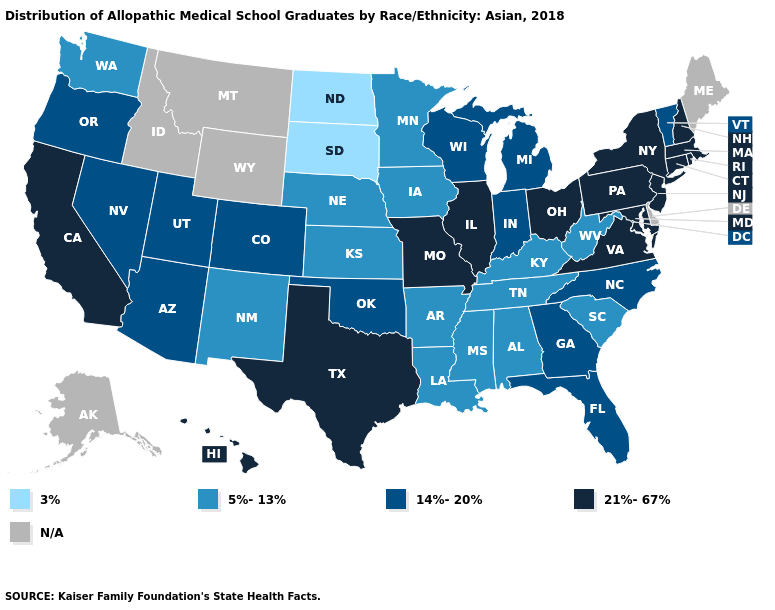Does Nevada have the highest value in the USA?
Short answer required. No. Name the states that have a value in the range 3%?
Write a very short answer. North Dakota, South Dakota. Does the map have missing data?
Answer briefly. Yes. Does North Carolina have the highest value in the USA?
Be succinct. No. Name the states that have a value in the range 3%?
Give a very brief answer. North Dakota, South Dakota. Which states have the highest value in the USA?
Give a very brief answer. California, Connecticut, Hawaii, Illinois, Maryland, Massachusetts, Missouri, New Hampshire, New Jersey, New York, Ohio, Pennsylvania, Rhode Island, Texas, Virginia. What is the value of North Dakota?
Answer briefly. 3%. Does Massachusetts have the highest value in the USA?
Keep it brief. Yes. What is the value of Michigan?
Write a very short answer. 14%-20%. Name the states that have a value in the range 14%-20%?
Keep it brief. Arizona, Colorado, Florida, Georgia, Indiana, Michigan, Nevada, North Carolina, Oklahoma, Oregon, Utah, Vermont, Wisconsin. Which states have the lowest value in the South?
Write a very short answer. Alabama, Arkansas, Kentucky, Louisiana, Mississippi, South Carolina, Tennessee, West Virginia. Does Ohio have the lowest value in the USA?
Write a very short answer. No. What is the value of Tennessee?
Quick response, please. 5%-13%. Which states have the lowest value in the USA?
Write a very short answer. North Dakota, South Dakota. 